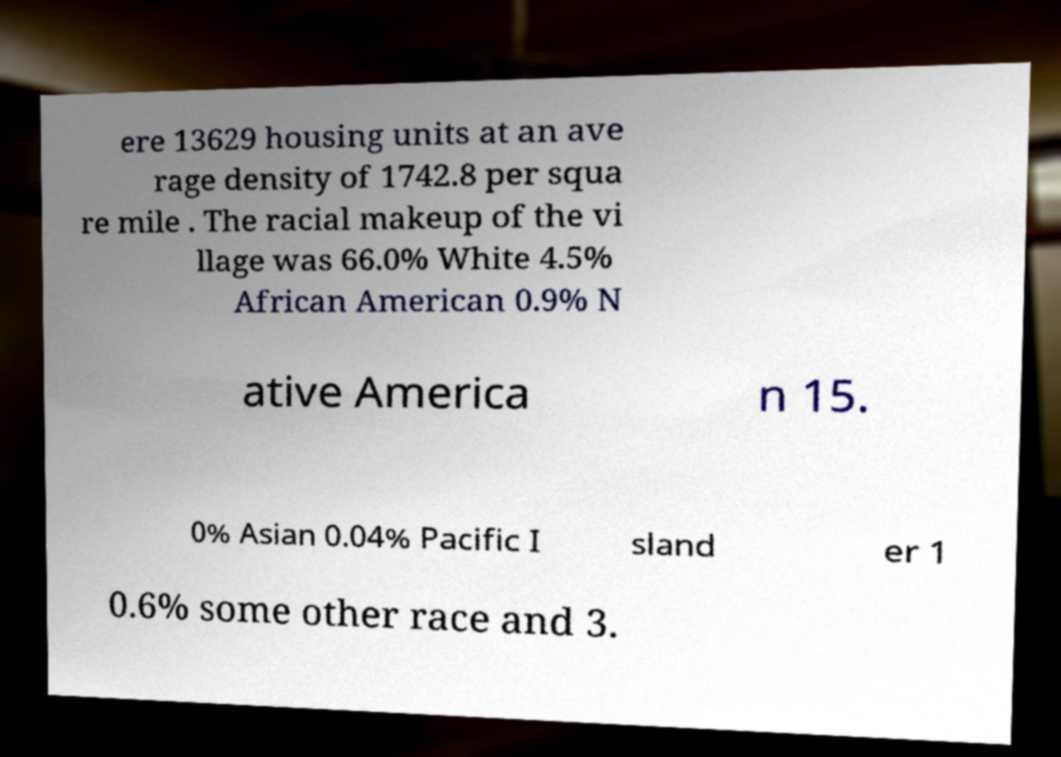What messages or text are displayed in this image? I need them in a readable, typed format. ere 13629 housing units at an ave rage density of 1742.8 per squa re mile . The racial makeup of the vi llage was 66.0% White 4.5% African American 0.9% N ative America n 15. 0% Asian 0.04% Pacific I sland er 1 0.6% some other race and 3. 